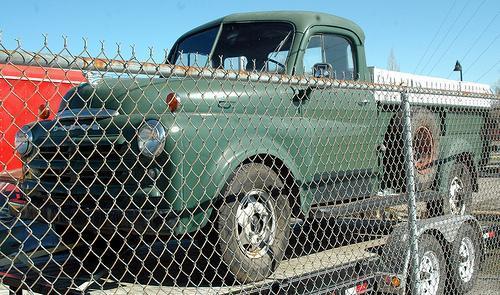How many vehicles?
Give a very brief answer. 1. How many tires are showing?
Give a very brief answer. 5. 